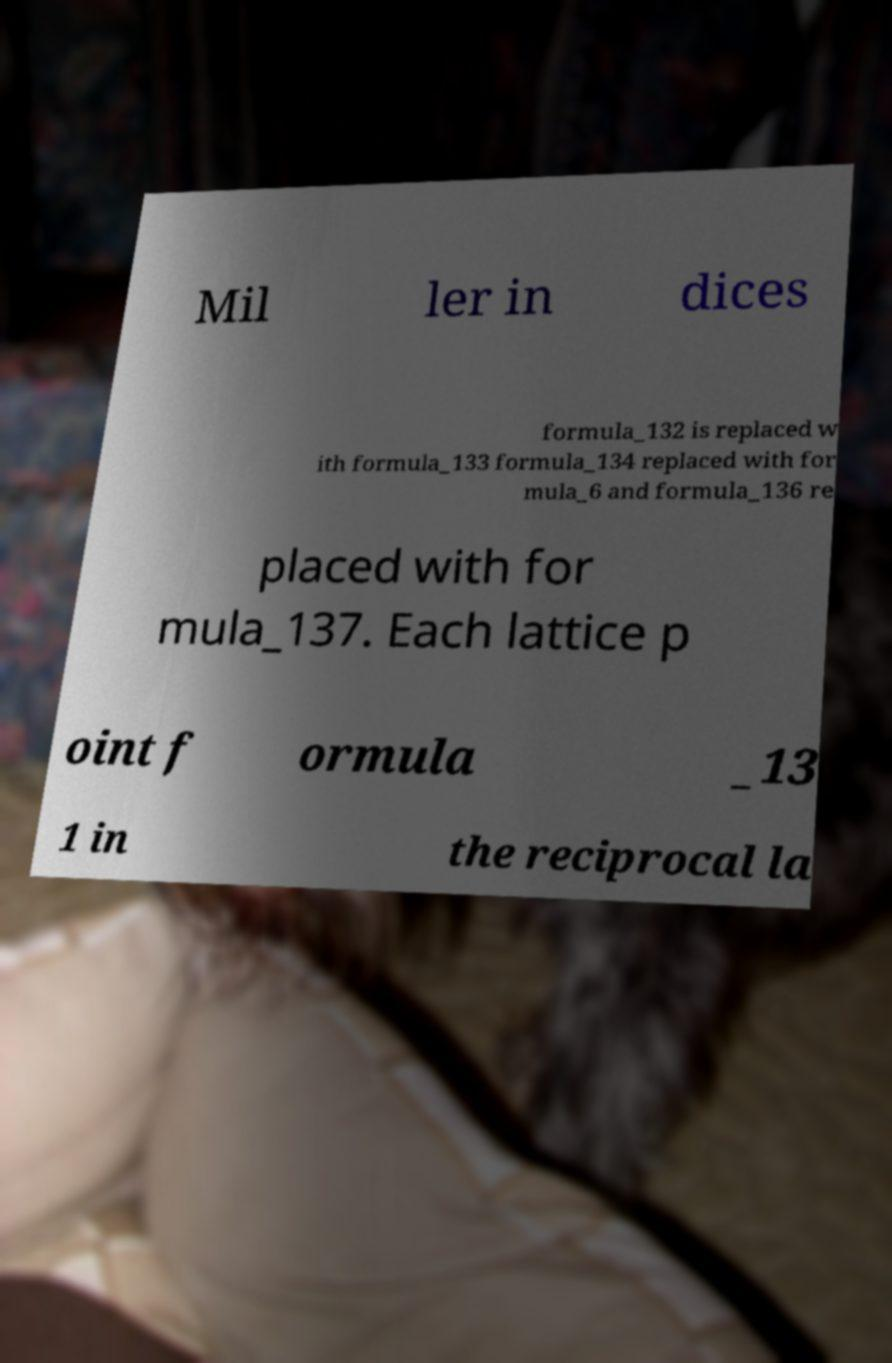There's text embedded in this image that I need extracted. Can you transcribe it verbatim? Mil ler in dices formula_132 is replaced w ith formula_133 formula_134 replaced with for mula_6 and formula_136 re placed with for mula_137. Each lattice p oint f ormula _13 1 in the reciprocal la 